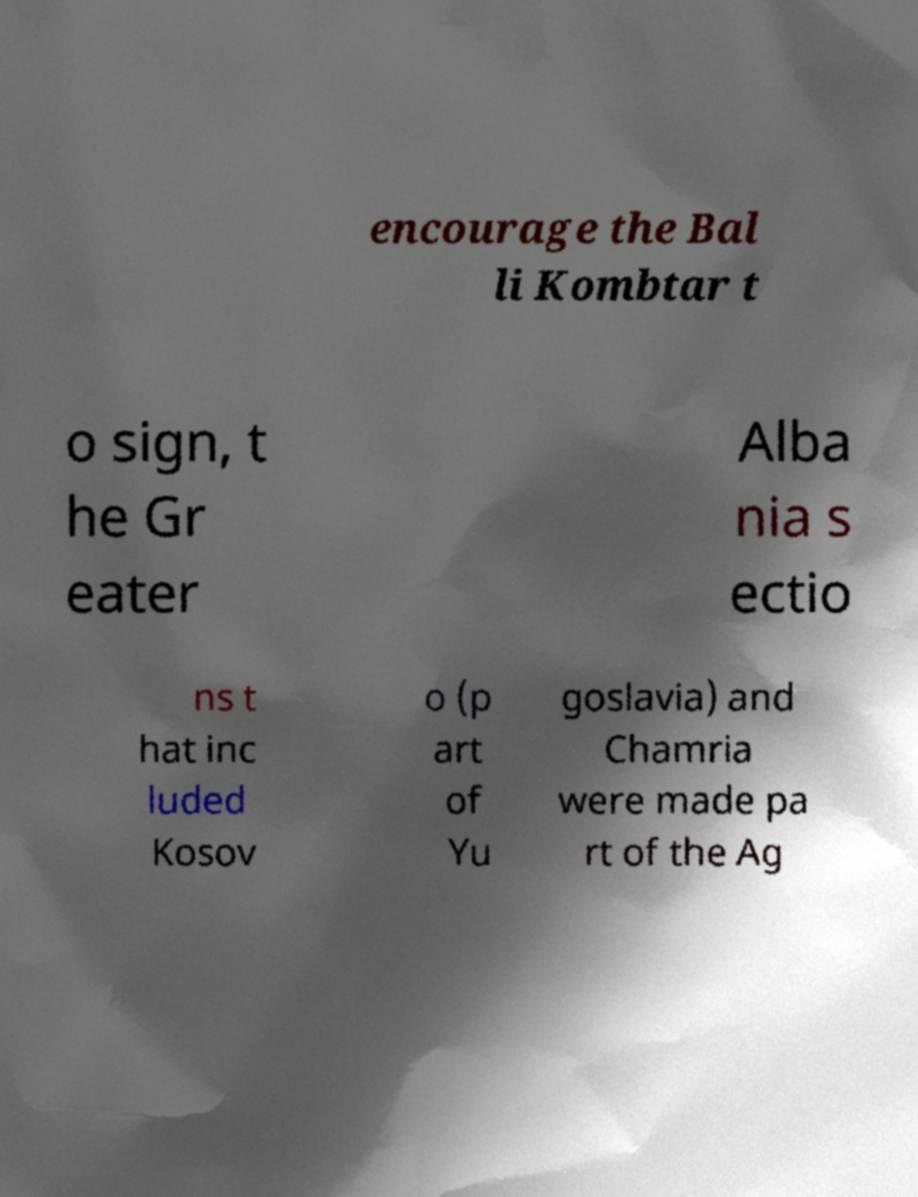Could you assist in decoding the text presented in this image and type it out clearly? encourage the Bal li Kombtar t o sign, t he Gr eater Alba nia s ectio ns t hat inc luded Kosov o (p art of Yu goslavia) and Chamria were made pa rt of the Ag 